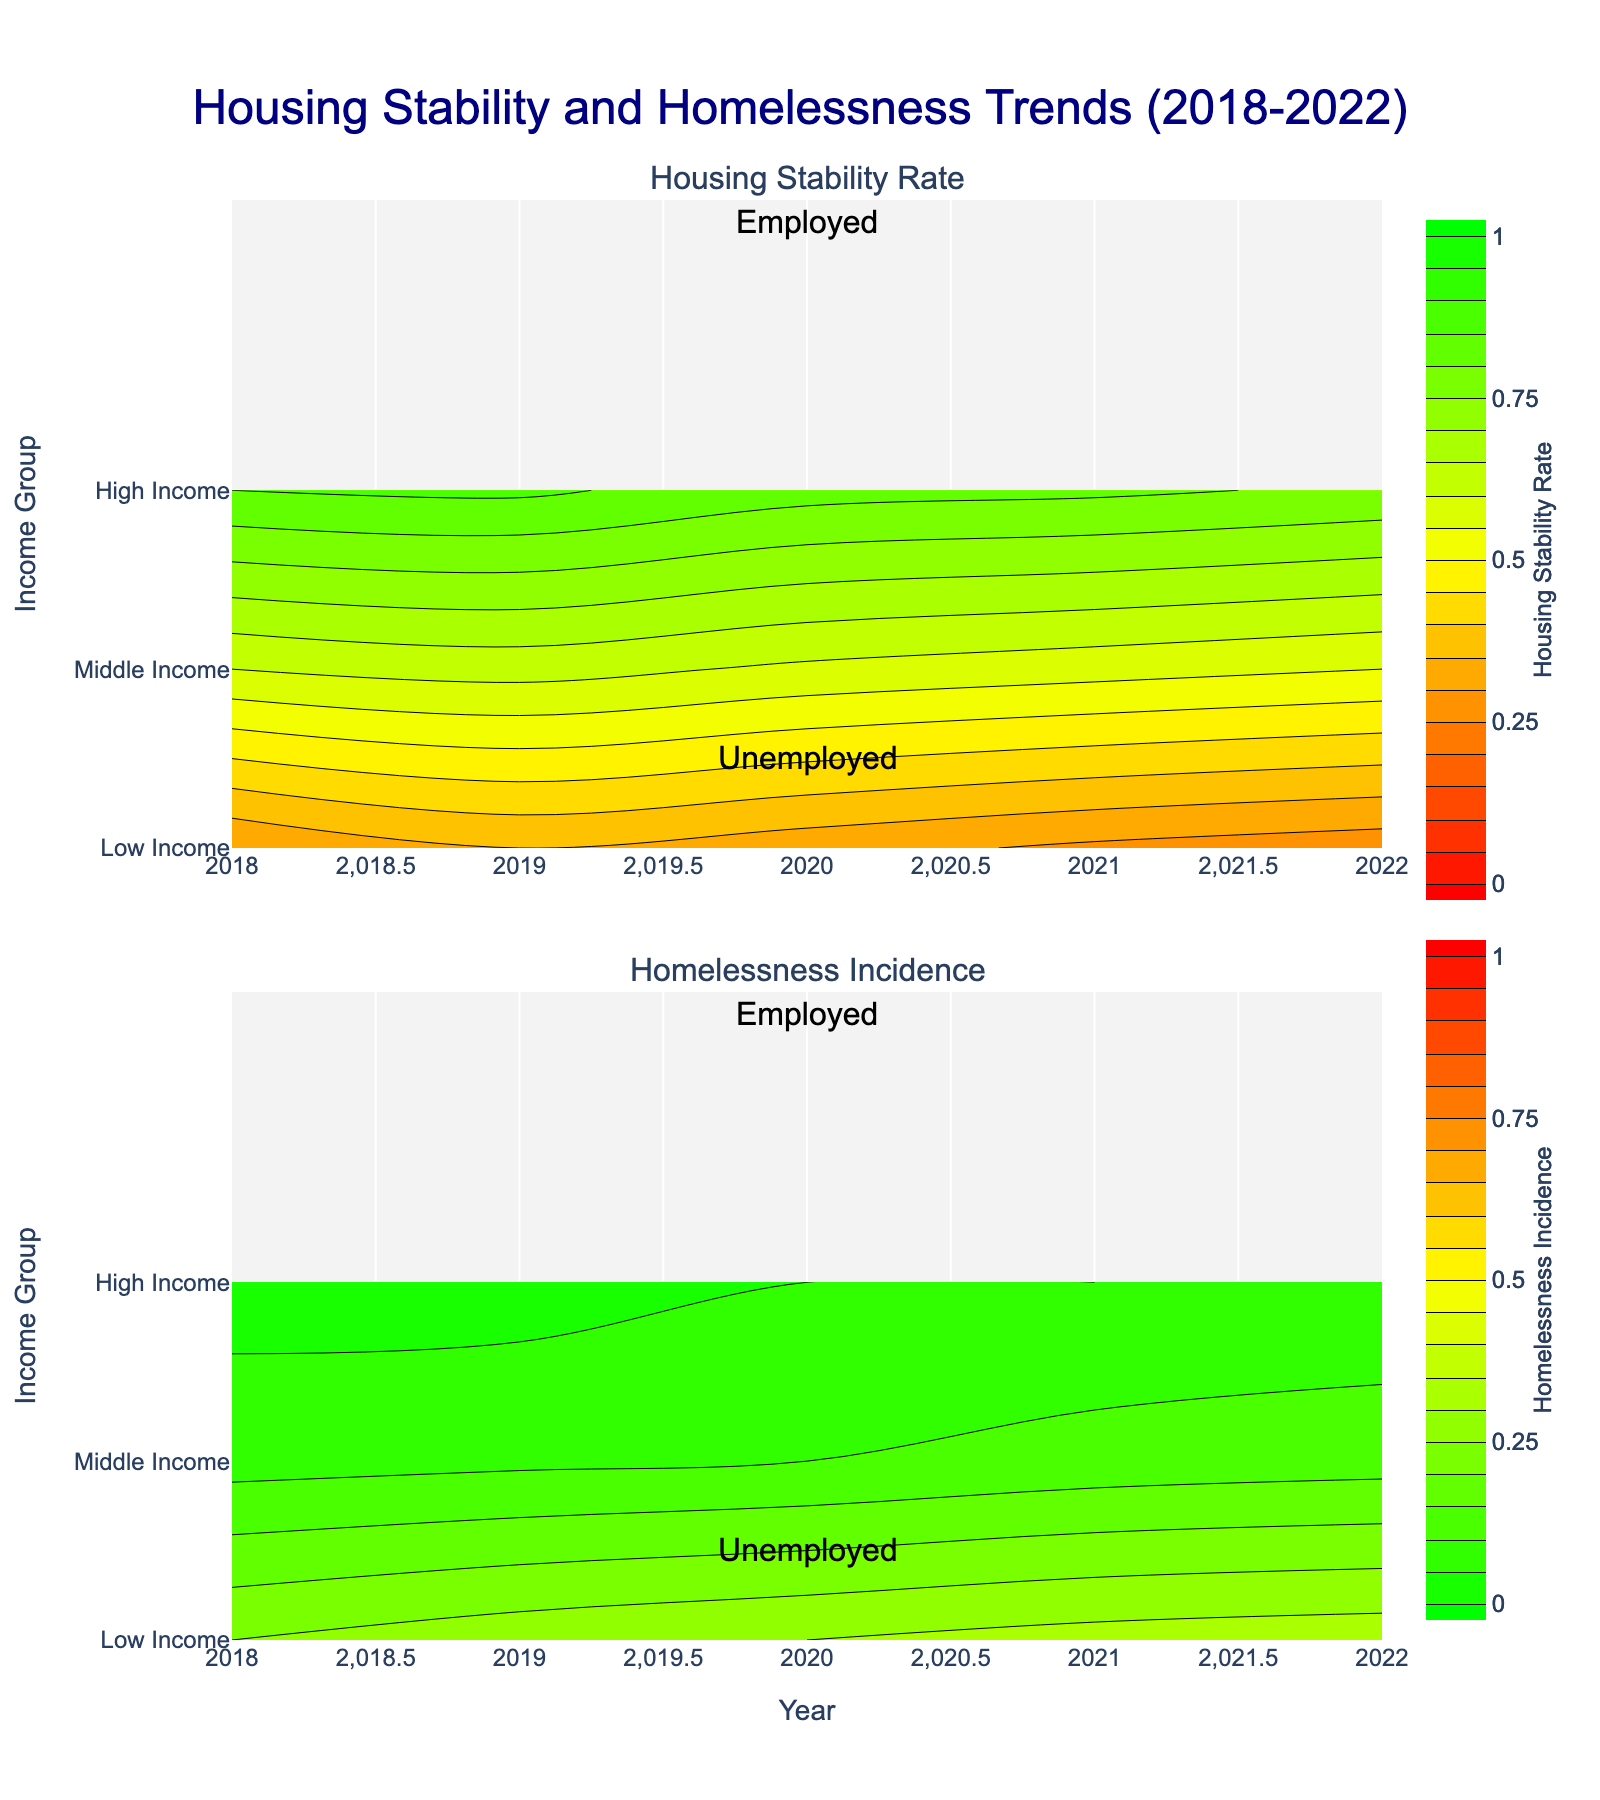How is the Housing Stability Rate trend for employed individuals across different income groups from 2018 to 2022? Look at the top subplot and observe the color bands for "Employed" annotation across "Low Income", "Middle Income", and "High Income" groups from the years 2018 to 2022. The gradient changes can indicate the trend.
Answer: The trend shows improvement over the years in low-income, stable for middle-income, and high stability for high-income groups Which income group had the highest Homelessness Incidence for unemployed individuals in 2022? Check the colors in the bottom subplot under "Unemployed" annotation across different income groups for the year 2022. The darkest red indicates the highest incidence.
Answer: Low Income What was the difference in Housing Stability Rate between employed and unemployed individuals in the Middle Income group in 2021? In the top subplot, compare the color shades for "Employed" and "Unemployed" annotations in the Middle Income group for 2021 and translate these colors back into numerical values.
Answer: 0.21 Which employment status group showed more homogeneity in Housing Stability over the years within the High Income group? Observe the consistency of color bands in the top subplot. Homogeneity can be interpreted from uniform color shades spanning the years.
Answer: Employed In which income group and employment status category did Homelessness Incidence remain almost constant from 2018 to 2022? Examine the bottom subplot for the uniform color pattern over the years.
Answer: High Income, Employed What's the average Housing Stability Rate for unemployed individuals across all income groups in 2022? Find the color in the top subplot for "Unemployed" annotation across "Low Income", "Middle Income", and "High Income" groups in 2022. Convert colors to values and average them.
Answer: (0.27 + 0.55 + 0.79) / 3 = 0.537 Compare the improvements in Housing Stability Rate for low-income employed and unemployed individuals between 2018 and 2022. Look at the differences in color in the top subplot for Low-Income groups under "Employed" and "Unemployed" annotations from 2018 to 2022. Determine the improvements from the shades' shifts.
Answer: Employed improved by 0.01, Unemployed declined by 0.03 